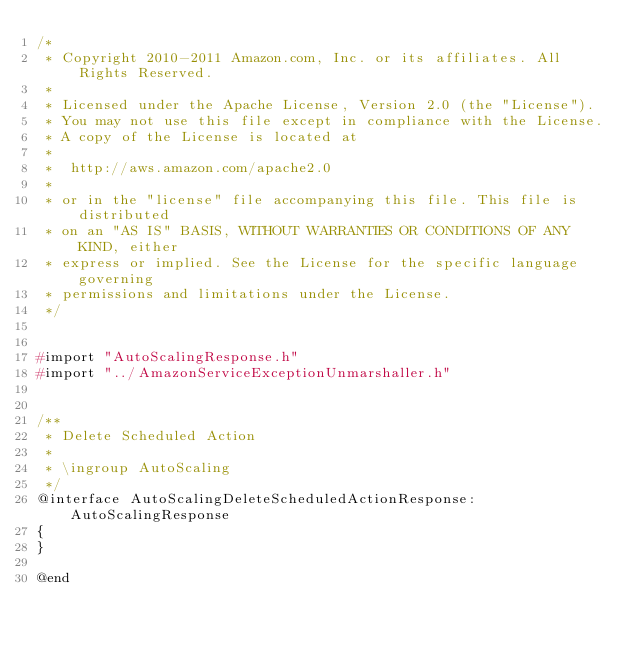Convert code to text. <code><loc_0><loc_0><loc_500><loc_500><_C_>/*
 * Copyright 2010-2011 Amazon.com, Inc. or its affiliates. All Rights Reserved.
 *
 * Licensed under the Apache License, Version 2.0 (the "License").
 * You may not use this file except in compliance with the License.
 * A copy of the License is located at
 *
 *  http://aws.amazon.com/apache2.0
 *
 * or in the "license" file accompanying this file. This file is distributed
 * on an "AS IS" BASIS, WITHOUT WARRANTIES OR CONDITIONS OF ANY KIND, either
 * express or implied. See the License for the specific language governing
 * permissions and limitations under the License.
 */


#import "AutoScalingResponse.h"
#import "../AmazonServiceExceptionUnmarshaller.h"


/**
 * Delete Scheduled Action
 *
 * \ingroup AutoScaling
 */
@interface AutoScalingDeleteScheduledActionResponse:AutoScalingResponse
{
}

@end
</code> 